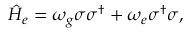<formula> <loc_0><loc_0><loc_500><loc_500>\begin{array} { r } { \hat { H } _ { e } = \omega _ { g } \sigma \sigma ^ { \dagger } + \omega _ { e } \sigma ^ { \dagger } \sigma , } \end{array}</formula> 